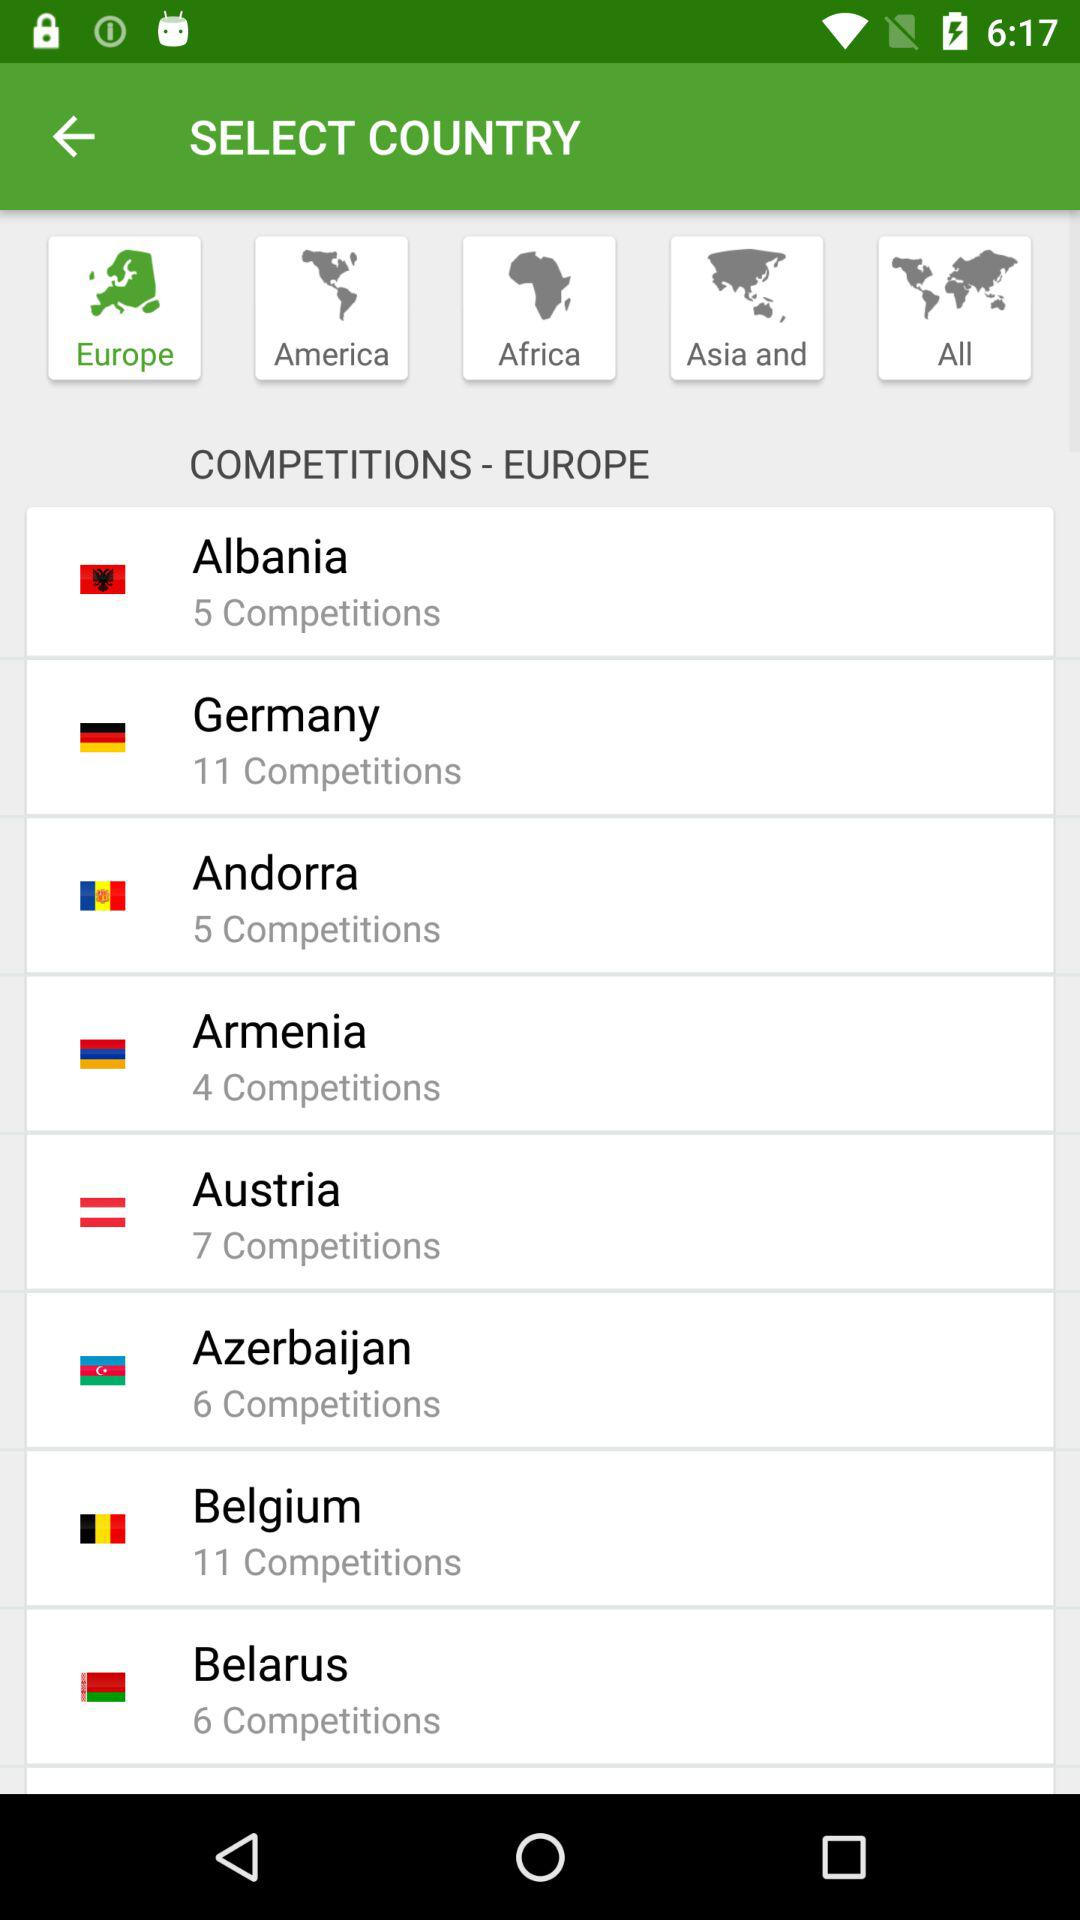How many competitions are there in Germany? There are 11 competitions in Germany. 